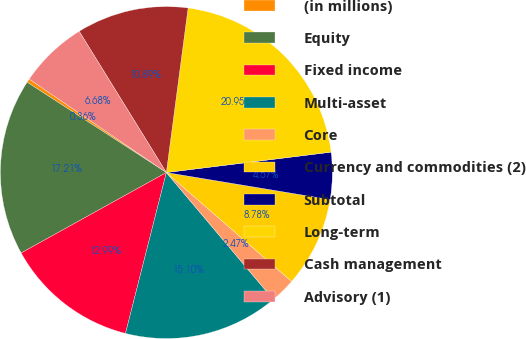<chart> <loc_0><loc_0><loc_500><loc_500><pie_chart><fcel>(in millions)<fcel>Equity<fcel>Fixed income<fcel>Multi-asset<fcel>Core<fcel>Currency and commodities (2)<fcel>Subtotal<fcel>Long-term<fcel>Cash management<fcel>Advisory (1)<nl><fcel>0.36%<fcel>17.21%<fcel>12.99%<fcel>15.1%<fcel>2.47%<fcel>8.78%<fcel>4.57%<fcel>20.95%<fcel>10.89%<fcel>6.68%<nl></chart> 